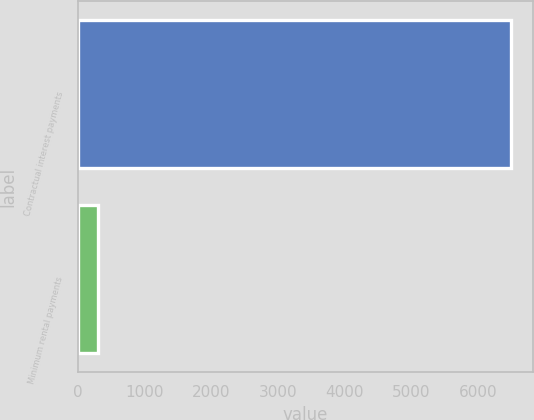Convert chart. <chart><loc_0><loc_0><loc_500><loc_500><bar_chart><fcel>Contractual interest payments<fcel>Minimum rental payments<nl><fcel>6497<fcel>299<nl></chart> 